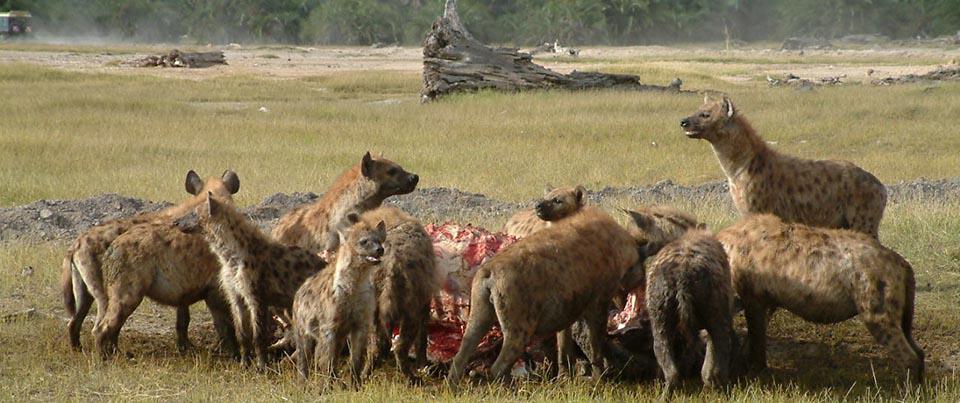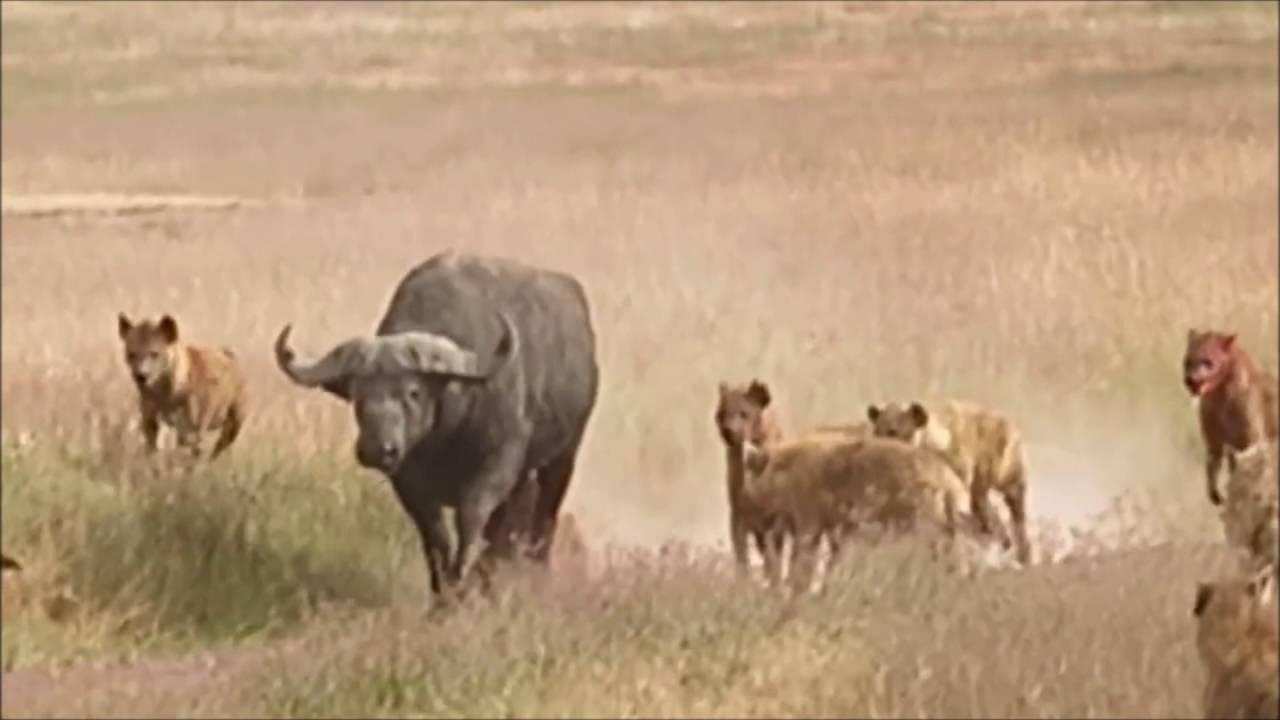The first image is the image on the left, the second image is the image on the right. Assess this claim about the two images: "One of the images shows hyenas hunting and the other shows them eating after a successful hunt.". Correct or not? Answer yes or no. Yes. The first image is the image on the left, the second image is the image on the right. Examine the images to the left and right. Is the description "One image includes one standing water buffalo in the foreground near multiple hyenas, and the other image shows a pack of hyenas gathered around something on the ground." accurate? Answer yes or no. Yes. 